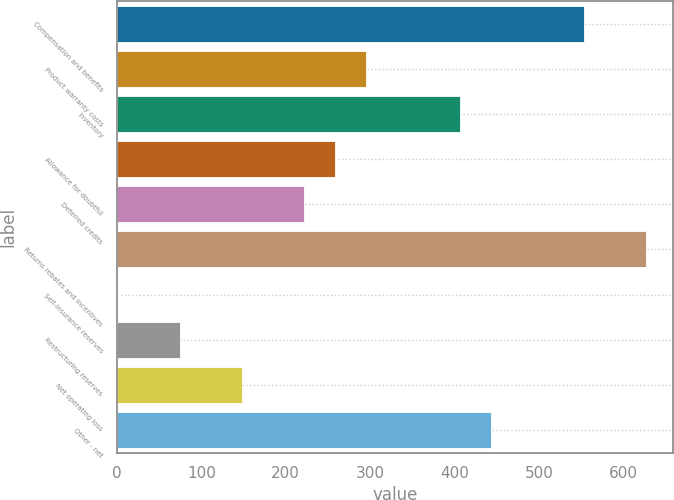<chart> <loc_0><loc_0><loc_500><loc_500><bar_chart><fcel>Compensation and benefits<fcel>Product warranty costs<fcel>Inventory<fcel>Allowance for doubtful<fcel>Deferred credits<fcel>Returns rebates and incentives<fcel>Self-insurance reserves<fcel>Restructuring reserves<fcel>Net operating loss<fcel>Other - net<nl><fcel>553.35<fcel>295.54<fcel>406.03<fcel>258.71<fcel>221.88<fcel>627.01<fcel>0.9<fcel>74.56<fcel>148.22<fcel>442.86<nl></chart> 